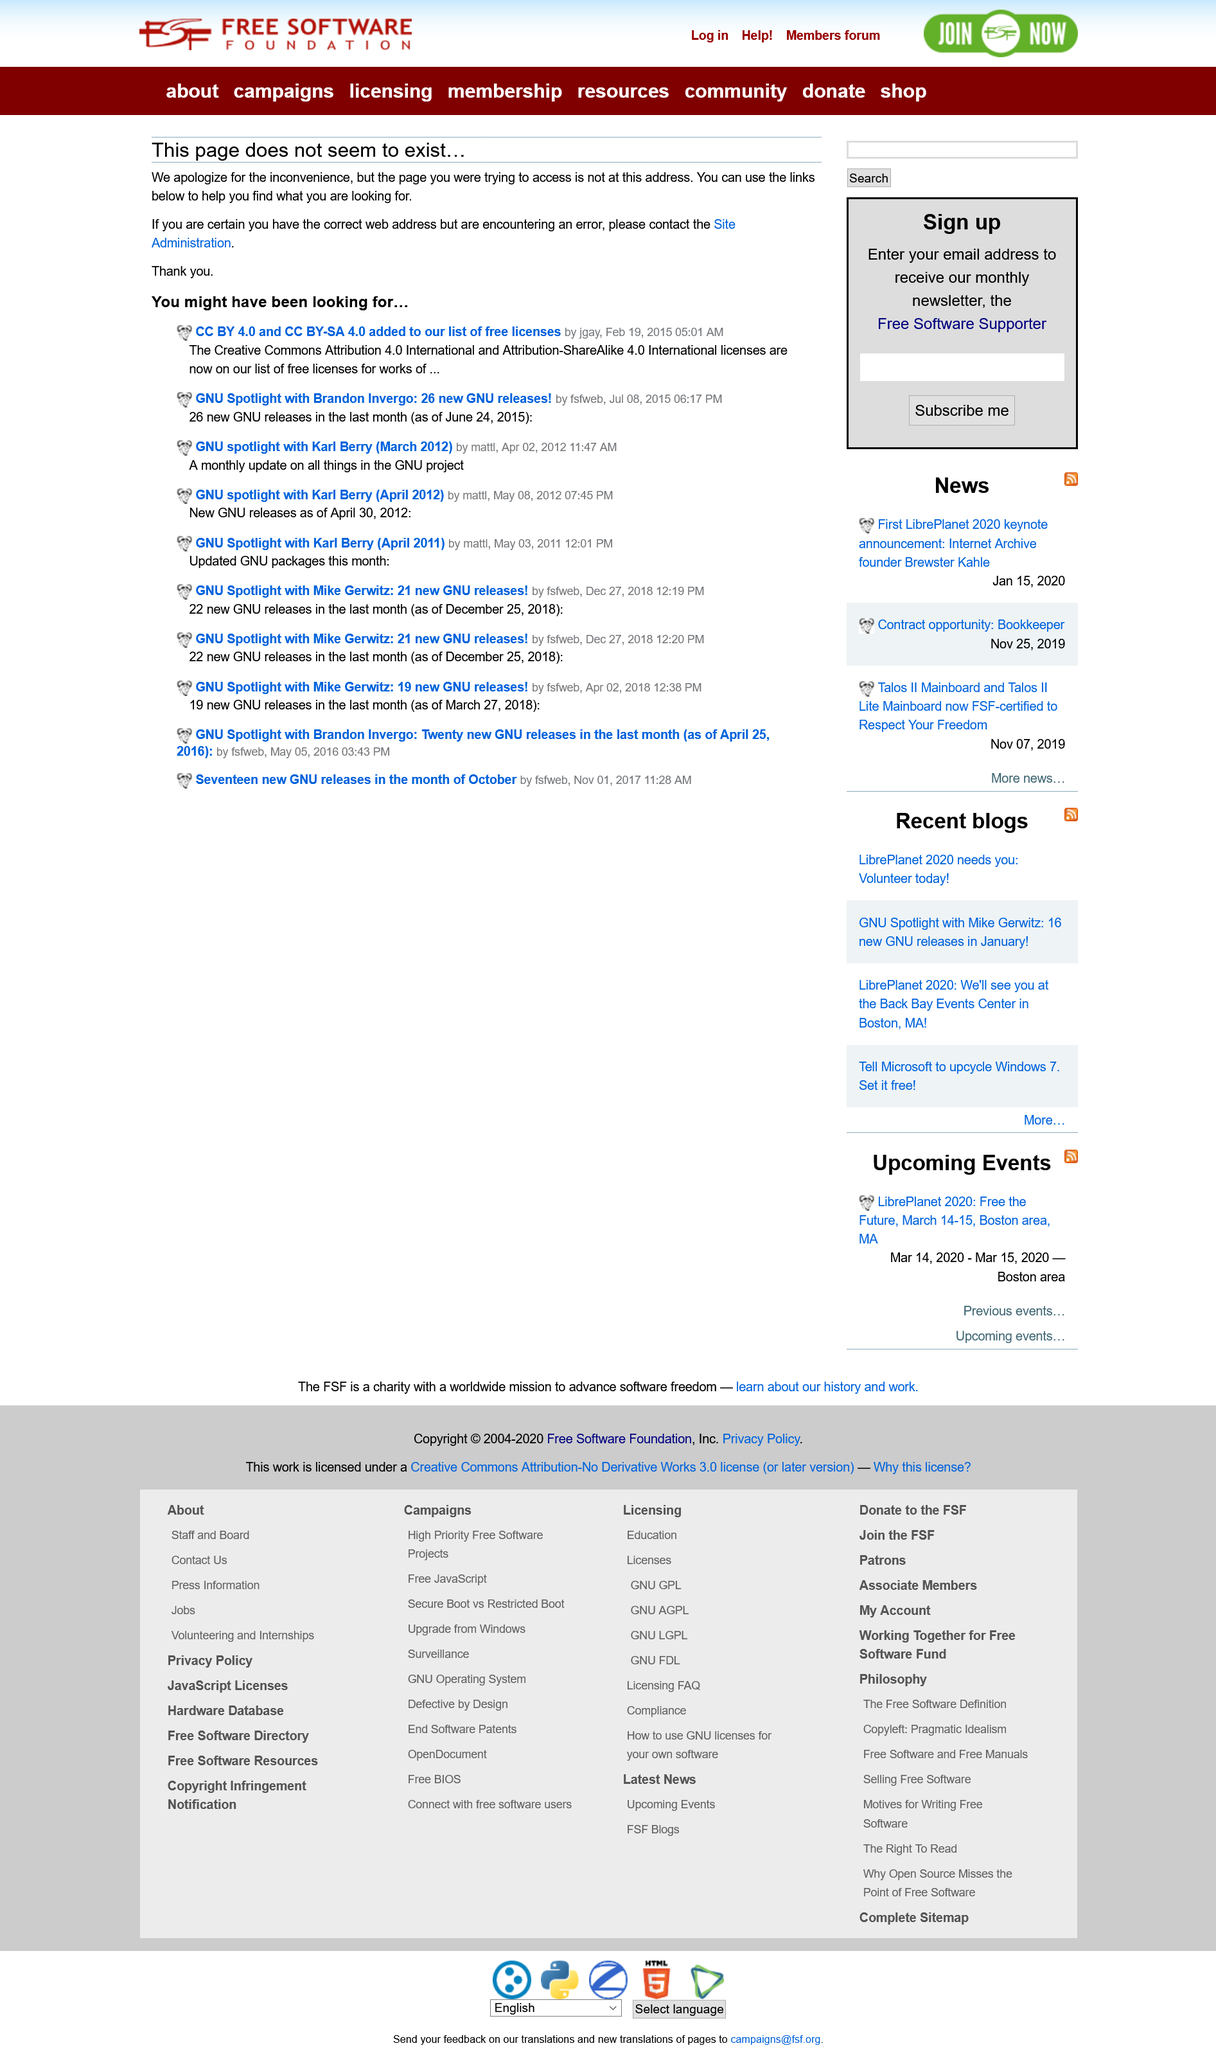List a handful of essential elements in this visual. Creative Commons" is an acronym that stands for "CC," which is a set of licenses that provide a standardized way for creators to give permission to others to use their creative works, such as images, videos, and texts, while retaining some rights for themselves. These licenses allow creators to specify how their works can be used, shared, and modified by others, and they are used by millions of creators around the world to share their work online. The list of free licenses now includes CC BY 4.0 and CC BY-SA 4.0. If you are certain that you have the right URL but are encountering an error, you should contact the Site Administrator. 